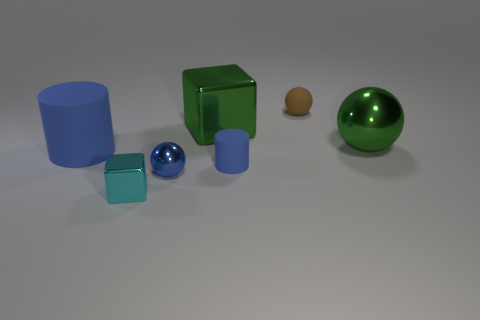Do the cube that is in front of the green ball and the ball behind the big cube have the same material?
Keep it short and to the point. No. Are there the same number of brown things left of the small brown matte object and large cyan balls?
Provide a succinct answer. Yes. Do the small cylinder and the small metal ball have the same color?
Offer a terse response. Yes. There is a big blue matte object to the left of the green ball; is it the same shape as the small rubber object that is left of the brown object?
Offer a very short reply. Yes. There is another object that is the same shape as the large blue matte object; what is it made of?
Provide a succinct answer. Rubber. What color is the matte thing that is to the right of the big blue matte cylinder and in front of the large metal ball?
Provide a short and direct response. Blue. There is a metallic cube that is in front of the small sphere in front of the green sphere; are there any cyan blocks that are on the left side of it?
Your answer should be very brief. No. How many things are either large blue rubber cylinders or tiny cyan metallic cubes?
Keep it short and to the point. 2. Is the material of the cyan cube the same as the green object that is behind the large green ball?
Your response must be concise. Yes. Are there any other things that are the same color as the small cube?
Provide a short and direct response. No. 